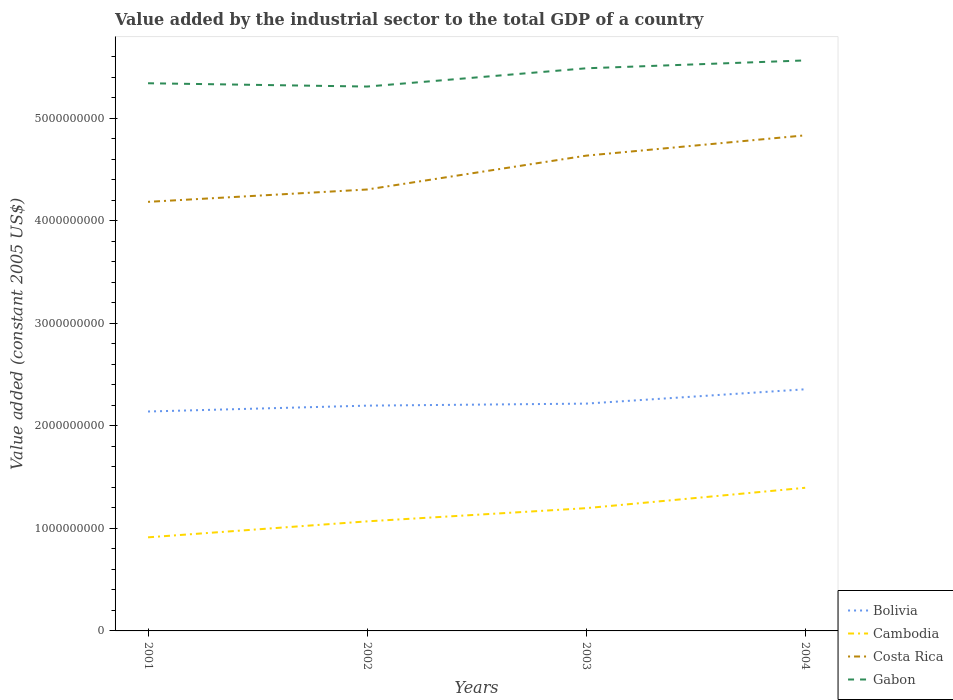Across all years, what is the maximum value added by the industrial sector in Costa Rica?
Your answer should be very brief. 4.18e+09. What is the total value added by the industrial sector in Cambodia in the graph?
Your response must be concise. -4.83e+08. What is the difference between the highest and the second highest value added by the industrial sector in Bolivia?
Your response must be concise. 2.17e+08. Is the value added by the industrial sector in Cambodia strictly greater than the value added by the industrial sector in Costa Rica over the years?
Provide a short and direct response. Yes. How many lines are there?
Provide a succinct answer. 4. What is the difference between two consecutive major ticks on the Y-axis?
Your response must be concise. 1.00e+09. Does the graph contain any zero values?
Provide a short and direct response. No. Does the graph contain grids?
Ensure brevity in your answer.  No. Where does the legend appear in the graph?
Offer a terse response. Bottom right. How many legend labels are there?
Your answer should be very brief. 4. What is the title of the graph?
Give a very brief answer. Value added by the industrial sector to the total GDP of a country. Does "Micronesia" appear as one of the legend labels in the graph?
Make the answer very short. No. What is the label or title of the X-axis?
Keep it short and to the point. Years. What is the label or title of the Y-axis?
Ensure brevity in your answer.  Value added (constant 2005 US$). What is the Value added (constant 2005 US$) of Bolivia in 2001?
Offer a terse response. 2.14e+09. What is the Value added (constant 2005 US$) of Cambodia in 2001?
Make the answer very short. 9.12e+08. What is the Value added (constant 2005 US$) of Costa Rica in 2001?
Make the answer very short. 4.18e+09. What is the Value added (constant 2005 US$) of Gabon in 2001?
Make the answer very short. 5.34e+09. What is the Value added (constant 2005 US$) in Bolivia in 2002?
Provide a succinct answer. 2.20e+09. What is the Value added (constant 2005 US$) of Cambodia in 2002?
Offer a terse response. 1.07e+09. What is the Value added (constant 2005 US$) in Costa Rica in 2002?
Your answer should be compact. 4.30e+09. What is the Value added (constant 2005 US$) in Gabon in 2002?
Offer a terse response. 5.31e+09. What is the Value added (constant 2005 US$) of Bolivia in 2003?
Give a very brief answer. 2.22e+09. What is the Value added (constant 2005 US$) in Cambodia in 2003?
Your answer should be compact. 1.20e+09. What is the Value added (constant 2005 US$) in Costa Rica in 2003?
Keep it short and to the point. 4.63e+09. What is the Value added (constant 2005 US$) in Gabon in 2003?
Make the answer very short. 5.49e+09. What is the Value added (constant 2005 US$) of Bolivia in 2004?
Offer a very short reply. 2.36e+09. What is the Value added (constant 2005 US$) of Cambodia in 2004?
Keep it short and to the point. 1.40e+09. What is the Value added (constant 2005 US$) in Costa Rica in 2004?
Keep it short and to the point. 4.83e+09. What is the Value added (constant 2005 US$) in Gabon in 2004?
Give a very brief answer. 5.56e+09. Across all years, what is the maximum Value added (constant 2005 US$) of Bolivia?
Ensure brevity in your answer.  2.36e+09. Across all years, what is the maximum Value added (constant 2005 US$) in Cambodia?
Ensure brevity in your answer.  1.40e+09. Across all years, what is the maximum Value added (constant 2005 US$) of Costa Rica?
Make the answer very short. 4.83e+09. Across all years, what is the maximum Value added (constant 2005 US$) of Gabon?
Provide a short and direct response. 5.56e+09. Across all years, what is the minimum Value added (constant 2005 US$) of Bolivia?
Offer a very short reply. 2.14e+09. Across all years, what is the minimum Value added (constant 2005 US$) in Cambodia?
Provide a succinct answer. 9.12e+08. Across all years, what is the minimum Value added (constant 2005 US$) of Costa Rica?
Make the answer very short. 4.18e+09. Across all years, what is the minimum Value added (constant 2005 US$) of Gabon?
Offer a very short reply. 5.31e+09. What is the total Value added (constant 2005 US$) of Bolivia in the graph?
Your answer should be very brief. 8.91e+09. What is the total Value added (constant 2005 US$) in Cambodia in the graph?
Give a very brief answer. 4.57e+09. What is the total Value added (constant 2005 US$) of Costa Rica in the graph?
Offer a terse response. 1.80e+1. What is the total Value added (constant 2005 US$) of Gabon in the graph?
Make the answer very short. 2.17e+1. What is the difference between the Value added (constant 2005 US$) in Bolivia in 2001 and that in 2002?
Provide a short and direct response. -5.73e+07. What is the difference between the Value added (constant 2005 US$) of Cambodia in 2001 and that in 2002?
Keep it short and to the point. -1.56e+08. What is the difference between the Value added (constant 2005 US$) in Costa Rica in 2001 and that in 2002?
Make the answer very short. -1.20e+08. What is the difference between the Value added (constant 2005 US$) in Gabon in 2001 and that in 2002?
Give a very brief answer. 3.22e+07. What is the difference between the Value added (constant 2005 US$) in Bolivia in 2001 and that in 2003?
Give a very brief answer. -7.70e+07. What is the difference between the Value added (constant 2005 US$) of Cambodia in 2001 and that in 2003?
Give a very brief answer. -2.84e+08. What is the difference between the Value added (constant 2005 US$) in Costa Rica in 2001 and that in 2003?
Offer a very short reply. -4.50e+08. What is the difference between the Value added (constant 2005 US$) in Gabon in 2001 and that in 2003?
Provide a succinct answer. -1.46e+08. What is the difference between the Value added (constant 2005 US$) in Bolivia in 2001 and that in 2004?
Your answer should be very brief. -2.17e+08. What is the difference between the Value added (constant 2005 US$) in Cambodia in 2001 and that in 2004?
Provide a succinct answer. -4.83e+08. What is the difference between the Value added (constant 2005 US$) in Costa Rica in 2001 and that in 2004?
Your answer should be compact. -6.49e+08. What is the difference between the Value added (constant 2005 US$) of Gabon in 2001 and that in 2004?
Offer a very short reply. -2.23e+08. What is the difference between the Value added (constant 2005 US$) in Bolivia in 2002 and that in 2003?
Your answer should be compact. -1.97e+07. What is the difference between the Value added (constant 2005 US$) of Cambodia in 2002 and that in 2003?
Give a very brief answer. -1.29e+08. What is the difference between the Value added (constant 2005 US$) in Costa Rica in 2002 and that in 2003?
Keep it short and to the point. -3.30e+08. What is the difference between the Value added (constant 2005 US$) in Gabon in 2002 and that in 2003?
Provide a succinct answer. -1.78e+08. What is the difference between the Value added (constant 2005 US$) in Bolivia in 2002 and that in 2004?
Keep it short and to the point. -1.59e+08. What is the difference between the Value added (constant 2005 US$) in Cambodia in 2002 and that in 2004?
Your answer should be compact. -3.27e+08. What is the difference between the Value added (constant 2005 US$) of Costa Rica in 2002 and that in 2004?
Your response must be concise. -5.28e+08. What is the difference between the Value added (constant 2005 US$) in Gabon in 2002 and that in 2004?
Keep it short and to the point. -2.55e+08. What is the difference between the Value added (constant 2005 US$) in Bolivia in 2003 and that in 2004?
Give a very brief answer. -1.40e+08. What is the difference between the Value added (constant 2005 US$) of Cambodia in 2003 and that in 2004?
Ensure brevity in your answer.  -1.99e+08. What is the difference between the Value added (constant 2005 US$) of Costa Rica in 2003 and that in 2004?
Make the answer very short. -1.98e+08. What is the difference between the Value added (constant 2005 US$) of Gabon in 2003 and that in 2004?
Ensure brevity in your answer.  -7.67e+07. What is the difference between the Value added (constant 2005 US$) of Bolivia in 2001 and the Value added (constant 2005 US$) of Cambodia in 2002?
Offer a terse response. 1.07e+09. What is the difference between the Value added (constant 2005 US$) of Bolivia in 2001 and the Value added (constant 2005 US$) of Costa Rica in 2002?
Your answer should be compact. -2.16e+09. What is the difference between the Value added (constant 2005 US$) in Bolivia in 2001 and the Value added (constant 2005 US$) in Gabon in 2002?
Keep it short and to the point. -3.17e+09. What is the difference between the Value added (constant 2005 US$) of Cambodia in 2001 and the Value added (constant 2005 US$) of Costa Rica in 2002?
Offer a very short reply. -3.39e+09. What is the difference between the Value added (constant 2005 US$) in Cambodia in 2001 and the Value added (constant 2005 US$) in Gabon in 2002?
Your answer should be compact. -4.40e+09. What is the difference between the Value added (constant 2005 US$) of Costa Rica in 2001 and the Value added (constant 2005 US$) of Gabon in 2002?
Your answer should be very brief. -1.12e+09. What is the difference between the Value added (constant 2005 US$) in Bolivia in 2001 and the Value added (constant 2005 US$) in Cambodia in 2003?
Offer a very short reply. 9.42e+08. What is the difference between the Value added (constant 2005 US$) in Bolivia in 2001 and the Value added (constant 2005 US$) in Costa Rica in 2003?
Ensure brevity in your answer.  -2.49e+09. What is the difference between the Value added (constant 2005 US$) of Bolivia in 2001 and the Value added (constant 2005 US$) of Gabon in 2003?
Your answer should be compact. -3.35e+09. What is the difference between the Value added (constant 2005 US$) in Cambodia in 2001 and the Value added (constant 2005 US$) in Costa Rica in 2003?
Ensure brevity in your answer.  -3.72e+09. What is the difference between the Value added (constant 2005 US$) of Cambodia in 2001 and the Value added (constant 2005 US$) of Gabon in 2003?
Provide a short and direct response. -4.57e+09. What is the difference between the Value added (constant 2005 US$) of Costa Rica in 2001 and the Value added (constant 2005 US$) of Gabon in 2003?
Ensure brevity in your answer.  -1.30e+09. What is the difference between the Value added (constant 2005 US$) in Bolivia in 2001 and the Value added (constant 2005 US$) in Cambodia in 2004?
Your response must be concise. 7.44e+08. What is the difference between the Value added (constant 2005 US$) of Bolivia in 2001 and the Value added (constant 2005 US$) of Costa Rica in 2004?
Your answer should be compact. -2.69e+09. What is the difference between the Value added (constant 2005 US$) of Bolivia in 2001 and the Value added (constant 2005 US$) of Gabon in 2004?
Make the answer very short. -3.42e+09. What is the difference between the Value added (constant 2005 US$) in Cambodia in 2001 and the Value added (constant 2005 US$) in Costa Rica in 2004?
Provide a short and direct response. -3.92e+09. What is the difference between the Value added (constant 2005 US$) of Cambodia in 2001 and the Value added (constant 2005 US$) of Gabon in 2004?
Give a very brief answer. -4.65e+09. What is the difference between the Value added (constant 2005 US$) in Costa Rica in 2001 and the Value added (constant 2005 US$) in Gabon in 2004?
Give a very brief answer. -1.38e+09. What is the difference between the Value added (constant 2005 US$) in Bolivia in 2002 and the Value added (constant 2005 US$) in Cambodia in 2003?
Offer a very short reply. 1.00e+09. What is the difference between the Value added (constant 2005 US$) in Bolivia in 2002 and the Value added (constant 2005 US$) in Costa Rica in 2003?
Keep it short and to the point. -2.44e+09. What is the difference between the Value added (constant 2005 US$) in Bolivia in 2002 and the Value added (constant 2005 US$) in Gabon in 2003?
Make the answer very short. -3.29e+09. What is the difference between the Value added (constant 2005 US$) of Cambodia in 2002 and the Value added (constant 2005 US$) of Costa Rica in 2003?
Ensure brevity in your answer.  -3.57e+09. What is the difference between the Value added (constant 2005 US$) of Cambodia in 2002 and the Value added (constant 2005 US$) of Gabon in 2003?
Provide a short and direct response. -4.42e+09. What is the difference between the Value added (constant 2005 US$) of Costa Rica in 2002 and the Value added (constant 2005 US$) of Gabon in 2003?
Your response must be concise. -1.18e+09. What is the difference between the Value added (constant 2005 US$) in Bolivia in 2002 and the Value added (constant 2005 US$) in Cambodia in 2004?
Provide a succinct answer. 8.01e+08. What is the difference between the Value added (constant 2005 US$) of Bolivia in 2002 and the Value added (constant 2005 US$) of Costa Rica in 2004?
Provide a short and direct response. -2.64e+09. What is the difference between the Value added (constant 2005 US$) in Bolivia in 2002 and the Value added (constant 2005 US$) in Gabon in 2004?
Your answer should be very brief. -3.37e+09. What is the difference between the Value added (constant 2005 US$) of Cambodia in 2002 and the Value added (constant 2005 US$) of Costa Rica in 2004?
Offer a terse response. -3.76e+09. What is the difference between the Value added (constant 2005 US$) in Cambodia in 2002 and the Value added (constant 2005 US$) in Gabon in 2004?
Keep it short and to the point. -4.49e+09. What is the difference between the Value added (constant 2005 US$) in Costa Rica in 2002 and the Value added (constant 2005 US$) in Gabon in 2004?
Provide a short and direct response. -1.26e+09. What is the difference between the Value added (constant 2005 US$) in Bolivia in 2003 and the Value added (constant 2005 US$) in Cambodia in 2004?
Ensure brevity in your answer.  8.21e+08. What is the difference between the Value added (constant 2005 US$) in Bolivia in 2003 and the Value added (constant 2005 US$) in Costa Rica in 2004?
Your answer should be compact. -2.62e+09. What is the difference between the Value added (constant 2005 US$) in Bolivia in 2003 and the Value added (constant 2005 US$) in Gabon in 2004?
Your answer should be very brief. -3.35e+09. What is the difference between the Value added (constant 2005 US$) in Cambodia in 2003 and the Value added (constant 2005 US$) in Costa Rica in 2004?
Keep it short and to the point. -3.64e+09. What is the difference between the Value added (constant 2005 US$) of Cambodia in 2003 and the Value added (constant 2005 US$) of Gabon in 2004?
Provide a short and direct response. -4.37e+09. What is the difference between the Value added (constant 2005 US$) in Costa Rica in 2003 and the Value added (constant 2005 US$) in Gabon in 2004?
Provide a succinct answer. -9.29e+08. What is the average Value added (constant 2005 US$) of Bolivia per year?
Give a very brief answer. 2.23e+09. What is the average Value added (constant 2005 US$) in Cambodia per year?
Your response must be concise. 1.14e+09. What is the average Value added (constant 2005 US$) in Costa Rica per year?
Offer a very short reply. 4.49e+09. What is the average Value added (constant 2005 US$) in Gabon per year?
Ensure brevity in your answer.  5.42e+09. In the year 2001, what is the difference between the Value added (constant 2005 US$) of Bolivia and Value added (constant 2005 US$) of Cambodia?
Your answer should be compact. 1.23e+09. In the year 2001, what is the difference between the Value added (constant 2005 US$) in Bolivia and Value added (constant 2005 US$) in Costa Rica?
Give a very brief answer. -2.04e+09. In the year 2001, what is the difference between the Value added (constant 2005 US$) of Bolivia and Value added (constant 2005 US$) of Gabon?
Make the answer very short. -3.20e+09. In the year 2001, what is the difference between the Value added (constant 2005 US$) in Cambodia and Value added (constant 2005 US$) in Costa Rica?
Ensure brevity in your answer.  -3.27e+09. In the year 2001, what is the difference between the Value added (constant 2005 US$) of Cambodia and Value added (constant 2005 US$) of Gabon?
Provide a short and direct response. -4.43e+09. In the year 2001, what is the difference between the Value added (constant 2005 US$) of Costa Rica and Value added (constant 2005 US$) of Gabon?
Your answer should be compact. -1.16e+09. In the year 2002, what is the difference between the Value added (constant 2005 US$) in Bolivia and Value added (constant 2005 US$) in Cambodia?
Give a very brief answer. 1.13e+09. In the year 2002, what is the difference between the Value added (constant 2005 US$) in Bolivia and Value added (constant 2005 US$) in Costa Rica?
Offer a terse response. -2.11e+09. In the year 2002, what is the difference between the Value added (constant 2005 US$) in Bolivia and Value added (constant 2005 US$) in Gabon?
Your response must be concise. -3.11e+09. In the year 2002, what is the difference between the Value added (constant 2005 US$) of Cambodia and Value added (constant 2005 US$) of Costa Rica?
Your response must be concise. -3.24e+09. In the year 2002, what is the difference between the Value added (constant 2005 US$) of Cambodia and Value added (constant 2005 US$) of Gabon?
Offer a terse response. -4.24e+09. In the year 2002, what is the difference between the Value added (constant 2005 US$) of Costa Rica and Value added (constant 2005 US$) of Gabon?
Your response must be concise. -1.00e+09. In the year 2003, what is the difference between the Value added (constant 2005 US$) in Bolivia and Value added (constant 2005 US$) in Cambodia?
Give a very brief answer. 1.02e+09. In the year 2003, what is the difference between the Value added (constant 2005 US$) in Bolivia and Value added (constant 2005 US$) in Costa Rica?
Your answer should be compact. -2.42e+09. In the year 2003, what is the difference between the Value added (constant 2005 US$) in Bolivia and Value added (constant 2005 US$) in Gabon?
Your answer should be compact. -3.27e+09. In the year 2003, what is the difference between the Value added (constant 2005 US$) of Cambodia and Value added (constant 2005 US$) of Costa Rica?
Give a very brief answer. -3.44e+09. In the year 2003, what is the difference between the Value added (constant 2005 US$) of Cambodia and Value added (constant 2005 US$) of Gabon?
Keep it short and to the point. -4.29e+09. In the year 2003, what is the difference between the Value added (constant 2005 US$) in Costa Rica and Value added (constant 2005 US$) in Gabon?
Give a very brief answer. -8.52e+08. In the year 2004, what is the difference between the Value added (constant 2005 US$) in Bolivia and Value added (constant 2005 US$) in Cambodia?
Make the answer very short. 9.60e+08. In the year 2004, what is the difference between the Value added (constant 2005 US$) in Bolivia and Value added (constant 2005 US$) in Costa Rica?
Ensure brevity in your answer.  -2.48e+09. In the year 2004, what is the difference between the Value added (constant 2005 US$) in Bolivia and Value added (constant 2005 US$) in Gabon?
Your answer should be compact. -3.21e+09. In the year 2004, what is the difference between the Value added (constant 2005 US$) in Cambodia and Value added (constant 2005 US$) in Costa Rica?
Make the answer very short. -3.44e+09. In the year 2004, what is the difference between the Value added (constant 2005 US$) of Cambodia and Value added (constant 2005 US$) of Gabon?
Provide a succinct answer. -4.17e+09. In the year 2004, what is the difference between the Value added (constant 2005 US$) in Costa Rica and Value added (constant 2005 US$) in Gabon?
Give a very brief answer. -7.30e+08. What is the ratio of the Value added (constant 2005 US$) in Bolivia in 2001 to that in 2002?
Provide a succinct answer. 0.97. What is the ratio of the Value added (constant 2005 US$) in Cambodia in 2001 to that in 2002?
Provide a short and direct response. 0.85. What is the ratio of the Value added (constant 2005 US$) in Gabon in 2001 to that in 2002?
Provide a short and direct response. 1.01. What is the ratio of the Value added (constant 2005 US$) in Bolivia in 2001 to that in 2003?
Provide a succinct answer. 0.97. What is the ratio of the Value added (constant 2005 US$) in Cambodia in 2001 to that in 2003?
Offer a terse response. 0.76. What is the ratio of the Value added (constant 2005 US$) of Costa Rica in 2001 to that in 2003?
Provide a short and direct response. 0.9. What is the ratio of the Value added (constant 2005 US$) in Gabon in 2001 to that in 2003?
Provide a short and direct response. 0.97. What is the ratio of the Value added (constant 2005 US$) of Bolivia in 2001 to that in 2004?
Your answer should be very brief. 0.91. What is the ratio of the Value added (constant 2005 US$) of Cambodia in 2001 to that in 2004?
Provide a succinct answer. 0.65. What is the ratio of the Value added (constant 2005 US$) of Costa Rica in 2001 to that in 2004?
Provide a short and direct response. 0.87. What is the ratio of the Value added (constant 2005 US$) of Cambodia in 2002 to that in 2003?
Make the answer very short. 0.89. What is the ratio of the Value added (constant 2005 US$) of Costa Rica in 2002 to that in 2003?
Your answer should be very brief. 0.93. What is the ratio of the Value added (constant 2005 US$) in Gabon in 2002 to that in 2003?
Give a very brief answer. 0.97. What is the ratio of the Value added (constant 2005 US$) of Bolivia in 2002 to that in 2004?
Provide a short and direct response. 0.93. What is the ratio of the Value added (constant 2005 US$) of Cambodia in 2002 to that in 2004?
Provide a succinct answer. 0.77. What is the ratio of the Value added (constant 2005 US$) in Costa Rica in 2002 to that in 2004?
Provide a short and direct response. 0.89. What is the ratio of the Value added (constant 2005 US$) of Gabon in 2002 to that in 2004?
Offer a terse response. 0.95. What is the ratio of the Value added (constant 2005 US$) of Bolivia in 2003 to that in 2004?
Your response must be concise. 0.94. What is the ratio of the Value added (constant 2005 US$) of Cambodia in 2003 to that in 2004?
Provide a short and direct response. 0.86. What is the ratio of the Value added (constant 2005 US$) in Gabon in 2003 to that in 2004?
Provide a short and direct response. 0.99. What is the difference between the highest and the second highest Value added (constant 2005 US$) in Bolivia?
Offer a terse response. 1.40e+08. What is the difference between the highest and the second highest Value added (constant 2005 US$) in Cambodia?
Make the answer very short. 1.99e+08. What is the difference between the highest and the second highest Value added (constant 2005 US$) of Costa Rica?
Offer a terse response. 1.98e+08. What is the difference between the highest and the second highest Value added (constant 2005 US$) of Gabon?
Offer a very short reply. 7.67e+07. What is the difference between the highest and the lowest Value added (constant 2005 US$) in Bolivia?
Offer a very short reply. 2.17e+08. What is the difference between the highest and the lowest Value added (constant 2005 US$) in Cambodia?
Provide a short and direct response. 4.83e+08. What is the difference between the highest and the lowest Value added (constant 2005 US$) in Costa Rica?
Your answer should be very brief. 6.49e+08. What is the difference between the highest and the lowest Value added (constant 2005 US$) of Gabon?
Provide a short and direct response. 2.55e+08. 